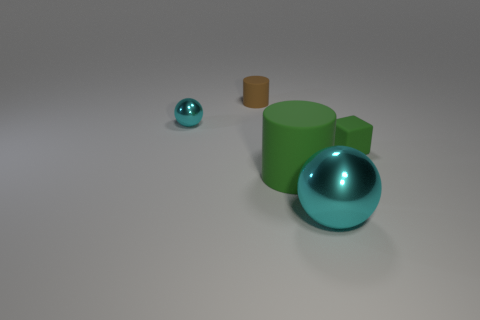Add 5 tiny green matte objects. How many objects exist? 10 Subtract all spheres. How many objects are left? 3 Add 4 green matte cubes. How many green matte cubes are left? 5 Add 1 green rubber cylinders. How many green rubber cylinders exist? 2 Subtract 2 cyan spheres. How many objects are left? 3 Subtract all tiny metallic objects. Subtract all small brown rubber cylinders. How many objects are left? 3 